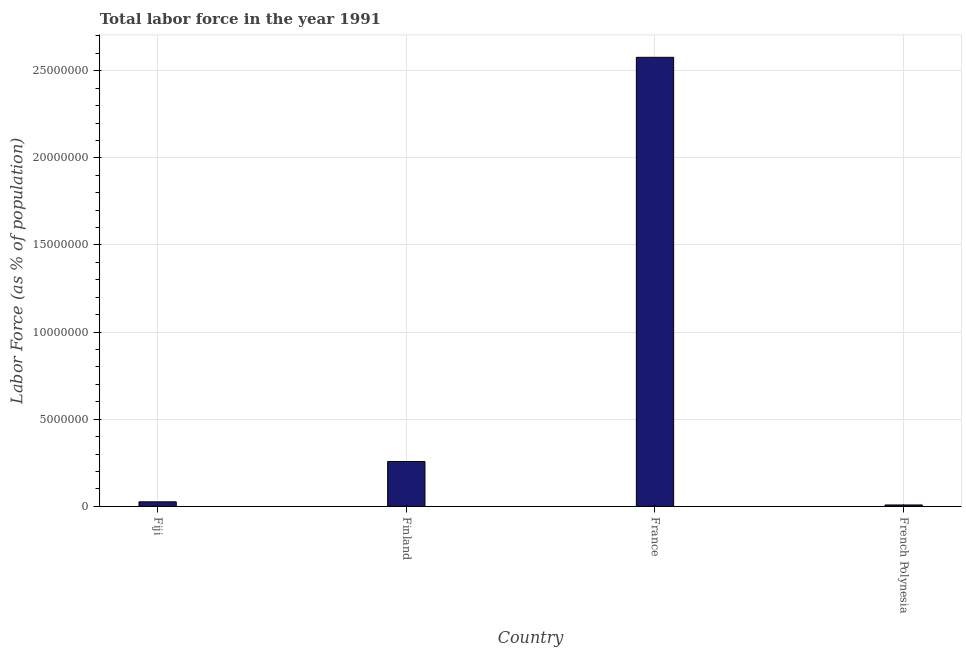Does the graph contain any zero values?
Ensure brevity in your answer.  No. What is the title of the graph?
Your response must be concise. Total labor force in the year 1991. What is the label or title of the X-axis?
Keep it short and to the point. Country. What is the label or title of the Y-axis?
Offer a terse response. Labor Force (as % of population). What is the total labor force in France?
Provide a short and direct response. 2.58e+07. Across all countries, what is the maximum total labor force?
Your answer should be compact. 2.58e+07. Across all countries, what is the minimum total labor force?
Keep it short and to the point. 7.91e+04. In which country was the total labor force minimum?
Your answer should be very brief. French Polynesia. What is the sum of the total labor force?
Your answer should be very brief. 2.87e+07. What is the difference between the total labor force in Fiji and Finland?
Offer a terse response. -2.32e+06. What is the average total labor force per country?
Make the answer very short. 7.17e+06. What is the median total labor force?
Keep it short and to the point. 1.42e+06. What is the ratio of the total labor force in Fiji to that in Finland?
Your response must be concise. 0.1. Is the total labor force in France less than that in French Polynesia?
Your answer should be very brief. No. Is the difference between the total labor force in Finland and French Polynesia greater than the difference between any two countries?
Keep it short and to the point. No. What is the difference between the highest and the second highest total labor force?
Offer a terse response. 2.32e+07. What is the difference between the highest and the lowest total labor force?
Provide a succinct answer. 2.57e+07. In how many countries, is the total labor force greater than the average total labor force taken over all countries?
Your answer should be very brief. 1. How many countries are there in the graph?
Make the answer very short. 4. What is the difference between two consecutive major ticks on the Y-axis?
Make the answer very short. 5.00e+06. Are the values on the major ticks of Y-axis written in scientific E-notation?
Your response must be concise. No. What is the Labor Force (as % of population) of Fiji?
Your response must be concise. 2.59e+05. What is the Labor Force (as % of population) in Finland?
Your response must be concise. 2.57e+06. What is the Labor Force (as % of population) of France?
Your answer should be very brief. 2.58e+07. What is the Labor Force (as % of population) of French Polynesia?
Your response must be concise. 7.91e+04. What is the difference between the Labor Force (as % of population) in Fiji and Finland?
Your response must be concise. -2.32e+06. What is the difference between the Labor Force (as % of population) in Fiji and France?
Provide a short and direct response. -2.55e+07. What is the difference between the Labor Force (as % of population) in Fiji and French Polynesia?
Make the answer very short. 1.80e+05. What is the difference between the Labor Force (as % of population) in Finland and France?
Your response must be concise. -2.32e+07. What is the difference between the Labor Force (as % of population) in Finland and French Polynesia?
Give a very brief answer. 2.50e+06. What is the difference between the Labor Force (as % of population) in France and French Polynesia?
Offer a terse response. 2.57e+07. What is the ratio of the Labor Force (as % of population) in Fiji to that in Finland?
Your answer should be very brief. 0.1. What is the ratio of the Labor Force (as % of population) in Fiji to that in French Polynesia?
Provide a short and direct response. 3.28. What is the ratio of the Labor Force (as % of population) in Finland to that in French Polynesia?
Your answer should be very brief. 32.54. What is the ratio of the Labor Force (as % of population) in France to that in French Polynesia?
Your answer should be compact. 325.67. 